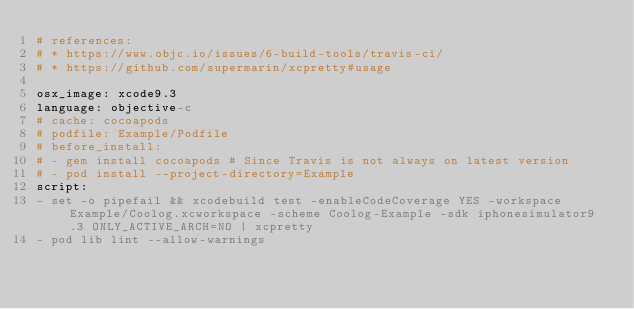Convert code to text. <code><loc_0><loc_0><loc_500><loc_500><_YAML_># references:
# * https://www.objc.io/issues/6-build-tools/travis-ci/
# * https://github.com/supermarin/xcpretty#usage

osx_image: xcode9.3
language: objective-c
# cache: cocoapods
# podfile: Example/Podfile
# before_install:
# - gem install cocoapods # Since Travis is not always on latest version
# - pod install --project-directory=Example
script:
- set -o pipefail && xcodebuild test -enableCodeCoverage YES -workspace Example/Coolog.xcworkspace -scheme Coolog-Example -sdk iphonesimulator9.3 ONLY_ACTIVE_ARCH=NO | xcpretty
- pod lib lint --allow-warnings
</code> 